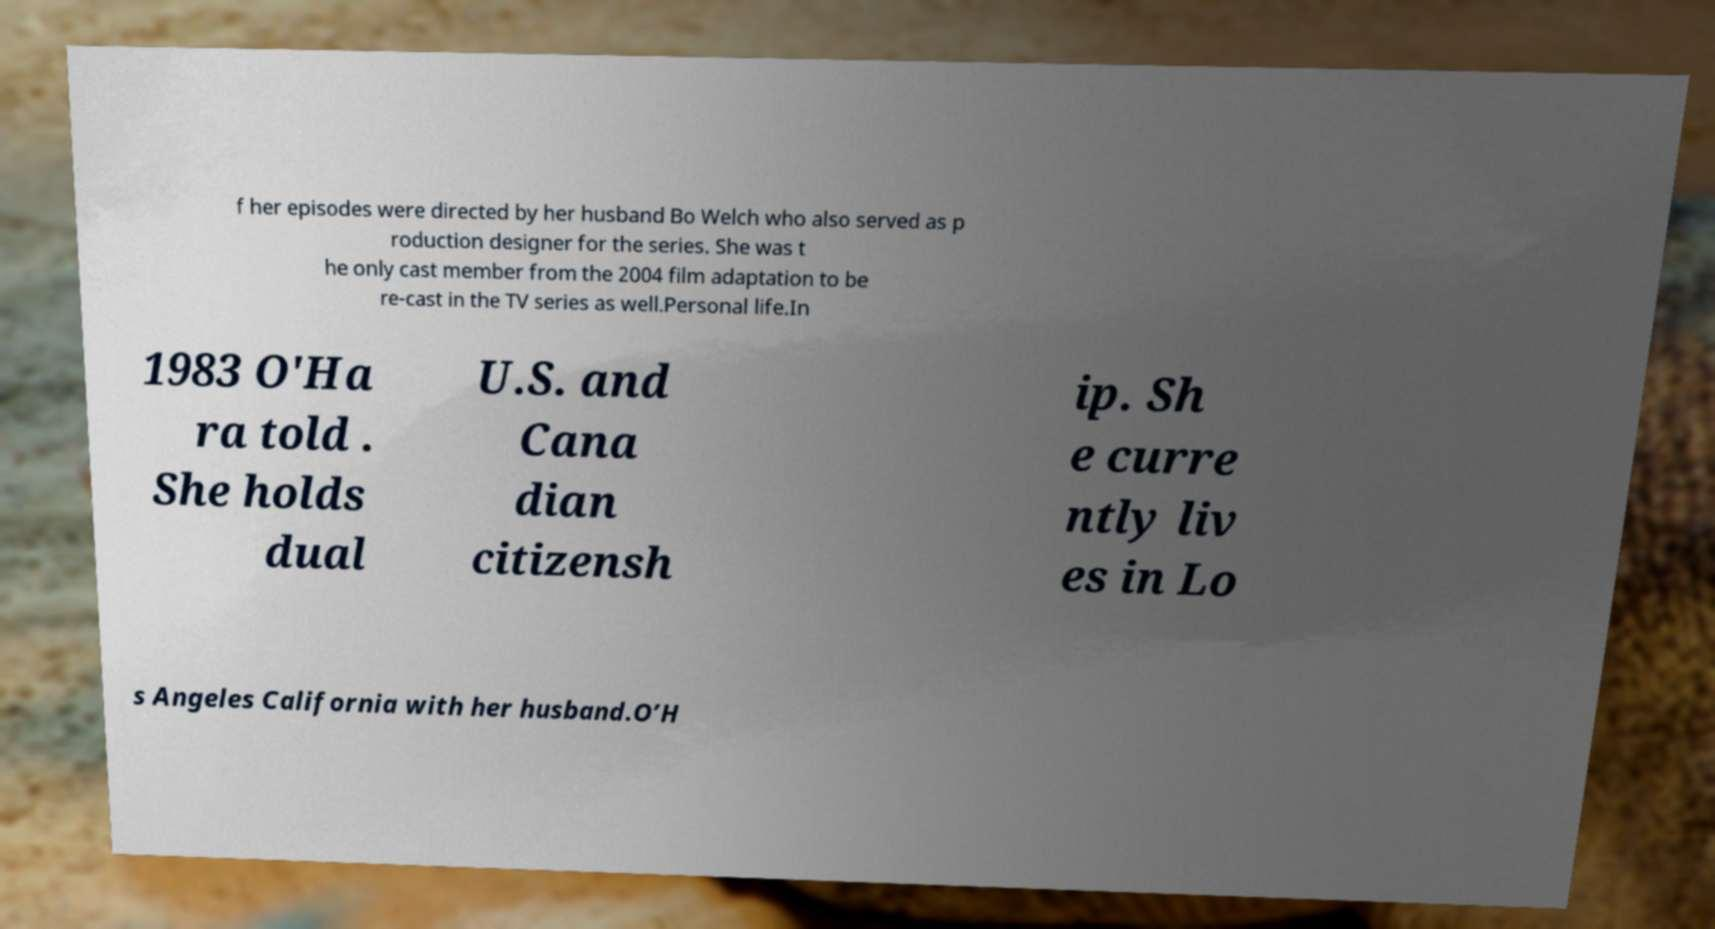Can you read and provide the text displayed in the image?This photo seems to have some interesting text. Can you extract and type it out for me? f her episodes were directed by her husband Bo Welch who also served as p roduction designer for the series. She was t he only cast member from the 2004 film adaptation to be re-cast in the TV series as well.Personal life.In 1983 O'Ha ra told . She holds dual U.S. and Cana dian citizensh ip. Sh e curre ntly liv es in Lo s Angeles California with her husband.O’H 